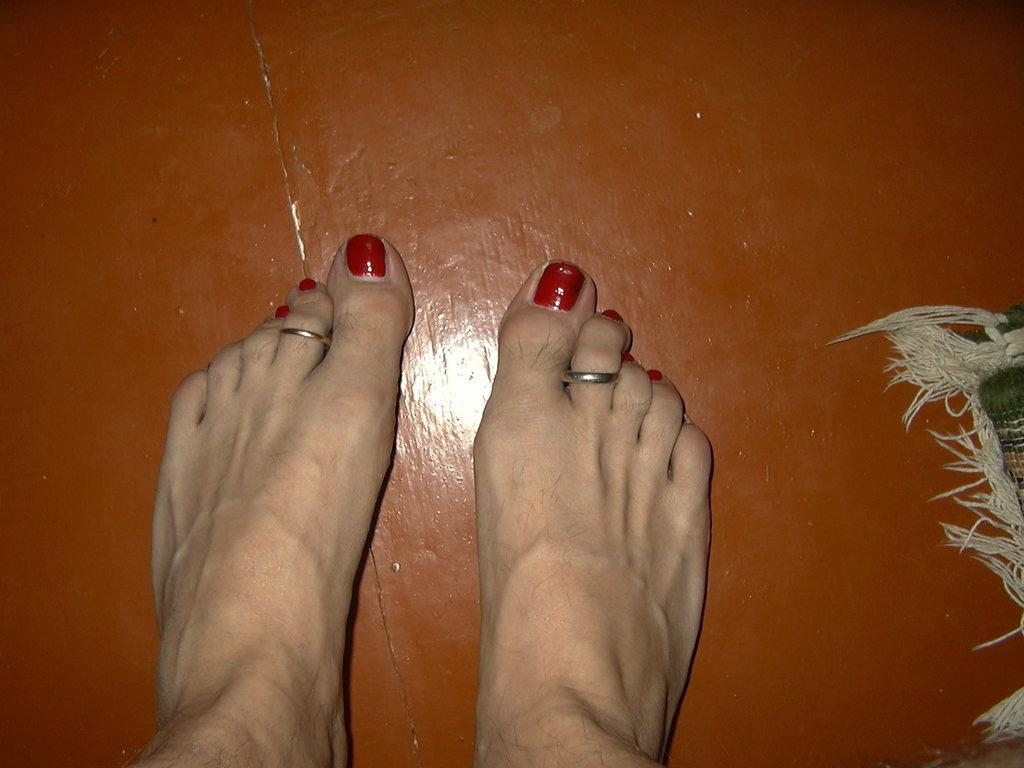What part of a person can be seen in the image? There are legs of a person visible in the image. What is on the floor in the image? There is a doormat on the floor in the image. How much salt is on the doormat in the image? There is no salt present on the doormat in the image. Can you see any crushed objects on the doormat in the image? There is no mention of crushed objects in the image, and the provided facts do not indicate their presence. 